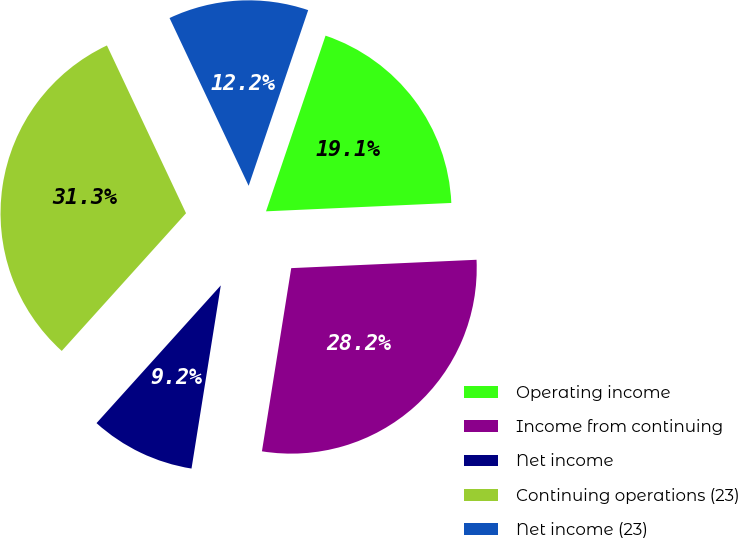Convert chart. <chart><loc_0><loc_0><loc_500><loc_500><pie_chart><fcel>Operating income<fcel>Income from continuing<fcel>Net income<fcel>Continuing operations (23)<fcel>Net income (23)<nl><fcel>19.08%<fcel>28.24%<fcel>9.16%<fcel>31.3%<fcel>12.21%<nl></chart> 